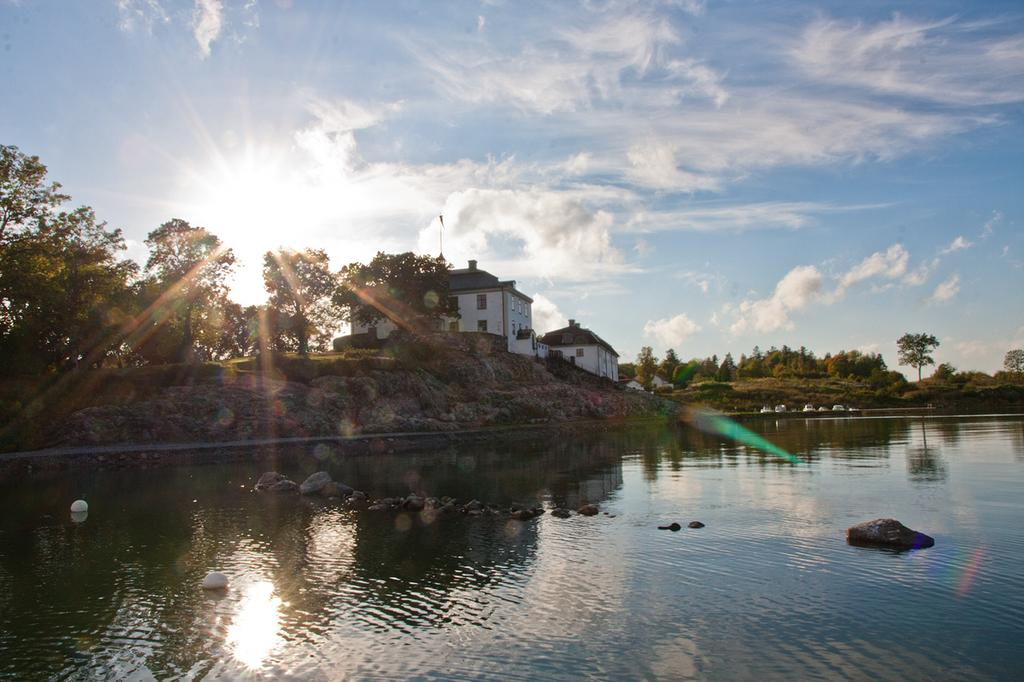What is the primary element visible in the image? There is water in the image. What other objects can be seen in the water? There are white colored objects on the surface of the water. What can be seen in the background of the image? There are buildings, trees, and the sky visible in the background of the image. Can the sun be seen in the sky? Yes, the sun is observable in the sky. What type of terrain is present in the image? There are rocks visible in the image. What type of reward is being given to the hands in the image? There are no hands present in the image, and therefore no reward can be given to them. 